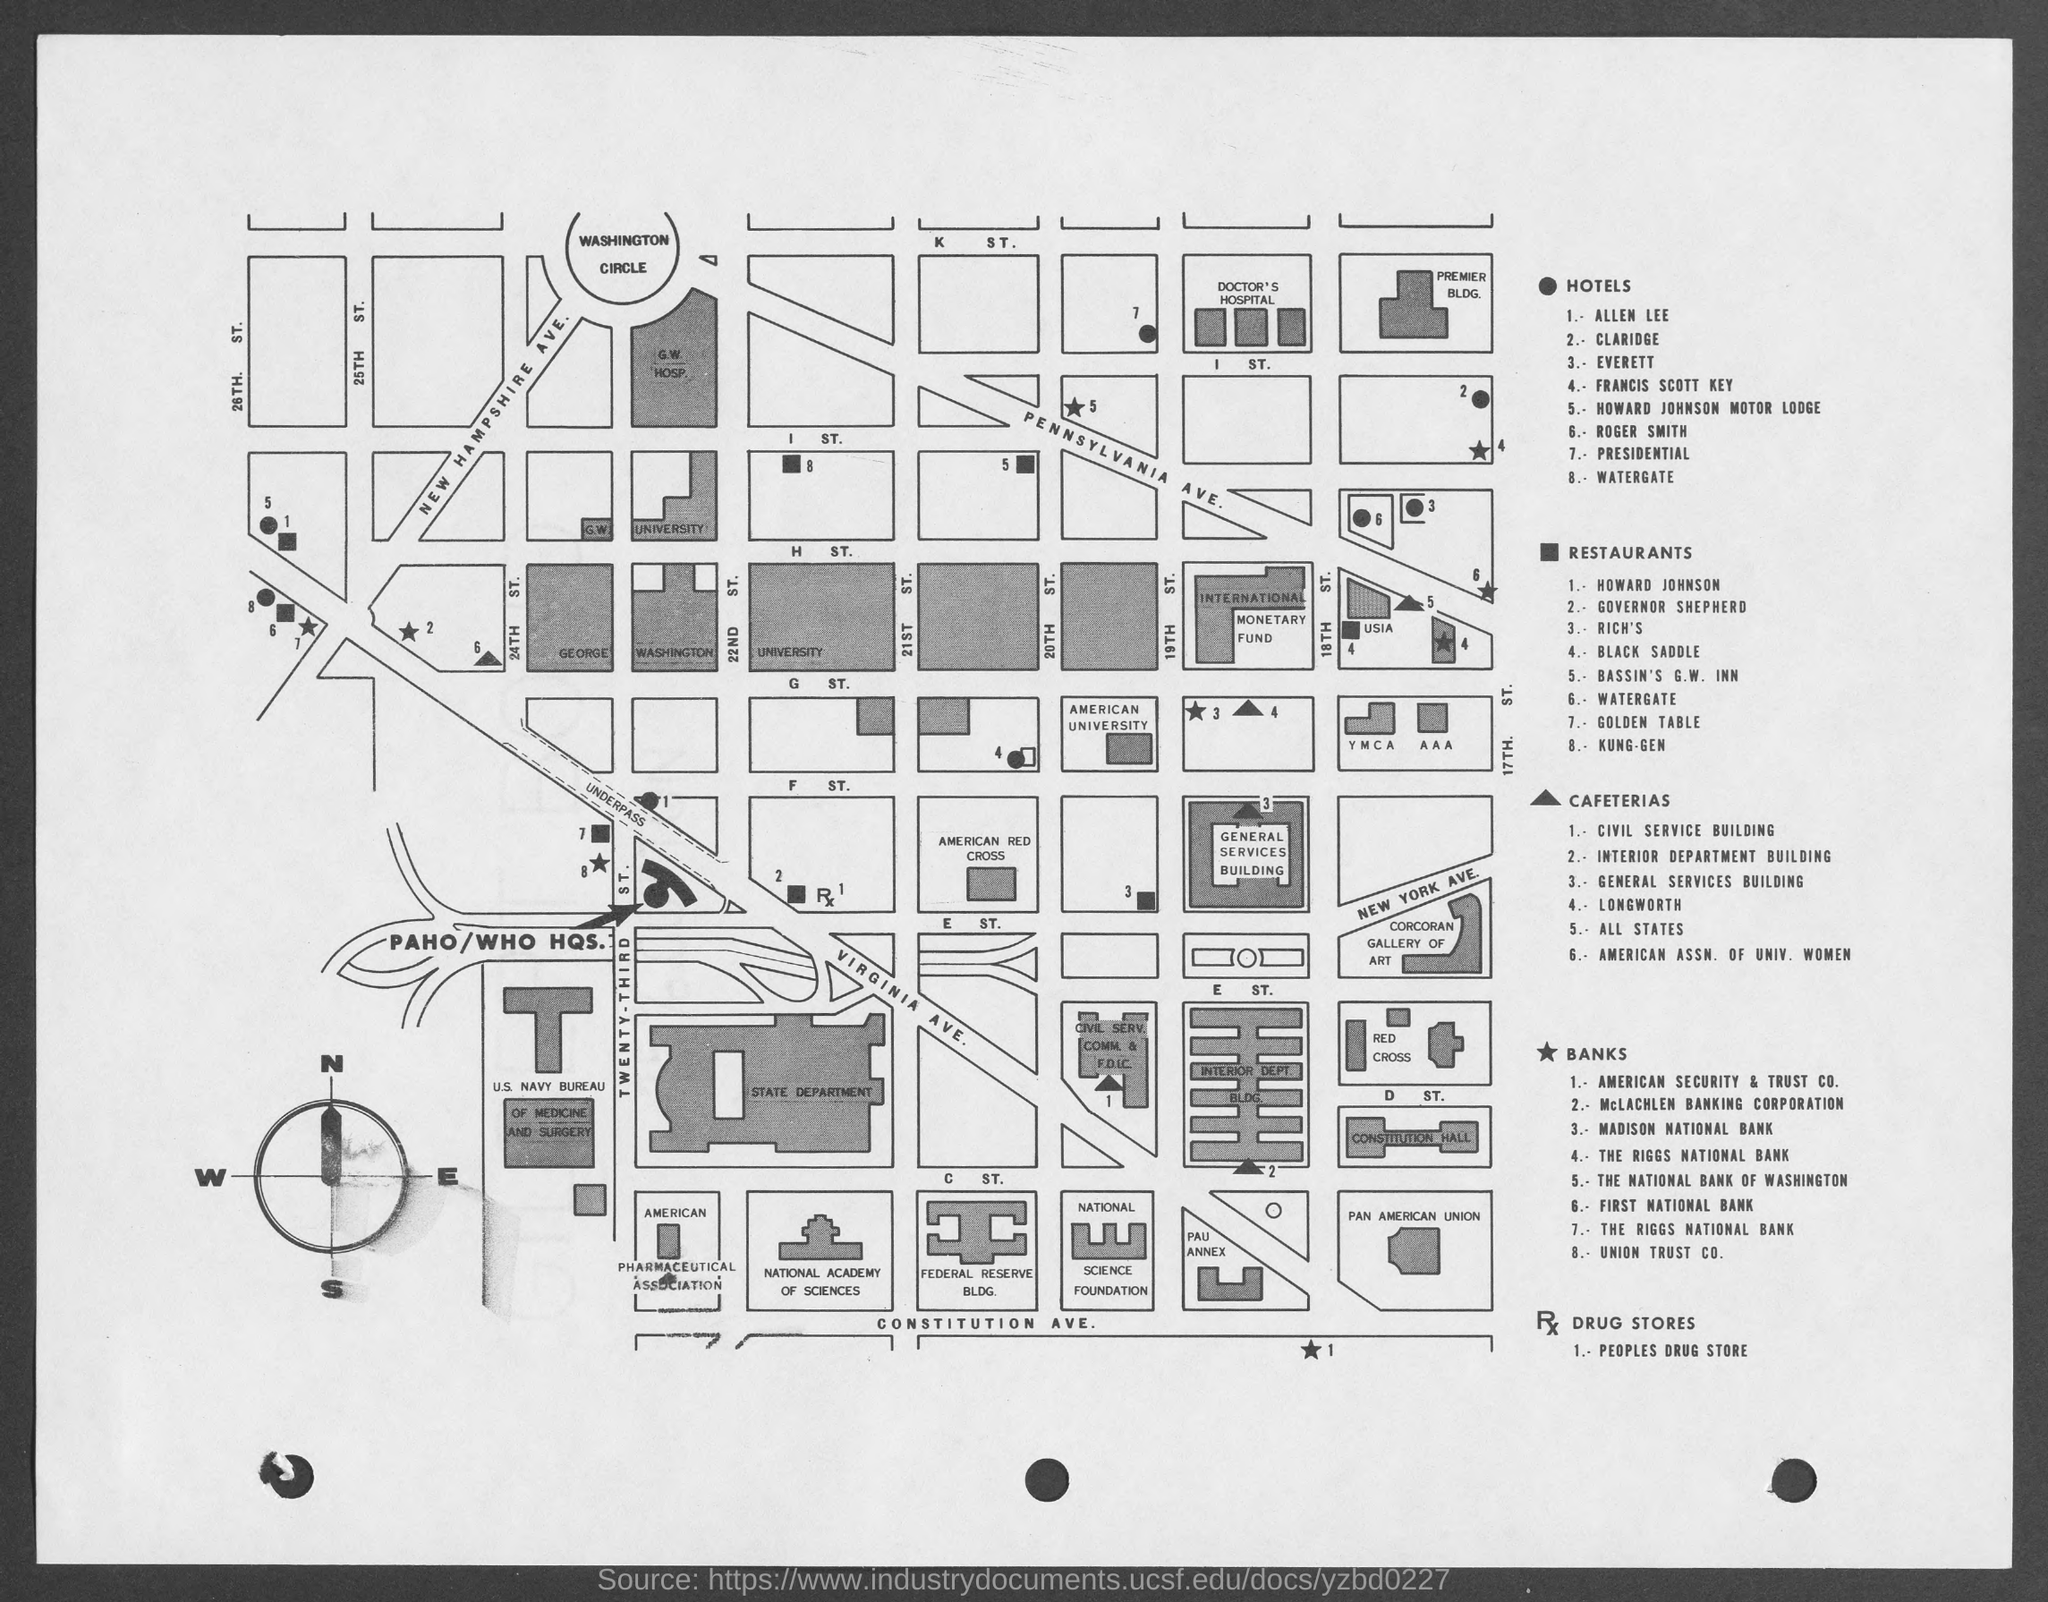How many hotels are there?
Your answer should be very brief. 8. How many restaurants are there?
Ensure brevity in your answer.  8. How many cafeterias are there?
Ensure brevity in your answer.  6. How many banks are there?
Ensure brevity in your answer.  8. How many drug stores are there?
Your answer should be very brief. 1. What is the name of the drug store?
Make the answer very short. Peoples Drug Store. The corcoran gallery of art is in which avenue?
Provide a succinct answer. New York Ave. 